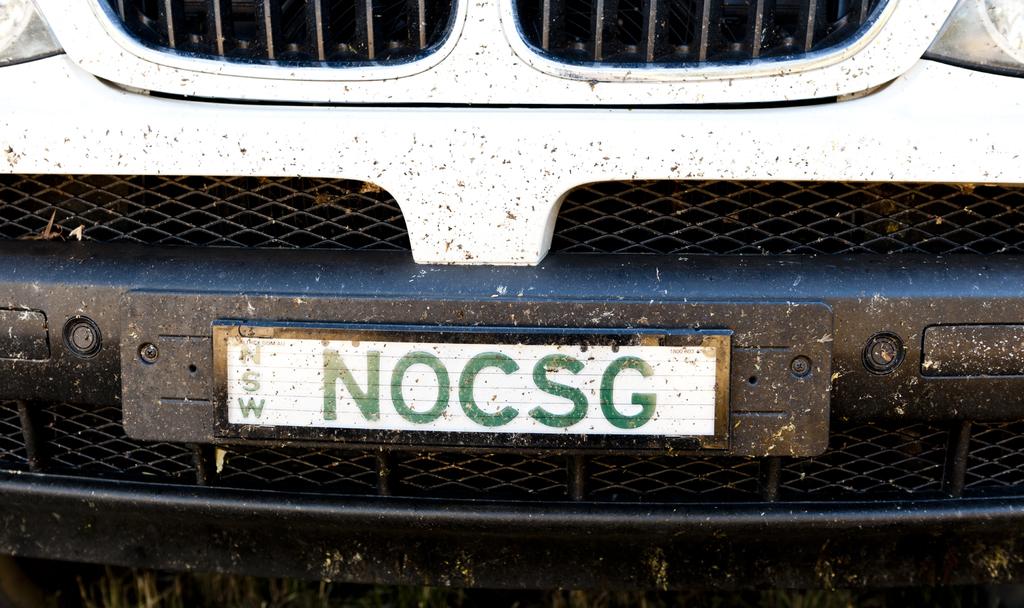What is this car's license plate number?
Give a very brief answer. Nocsg. What is the subscript on the left of the licence plate?
Ensure brevity in your answer.  Nsw. 